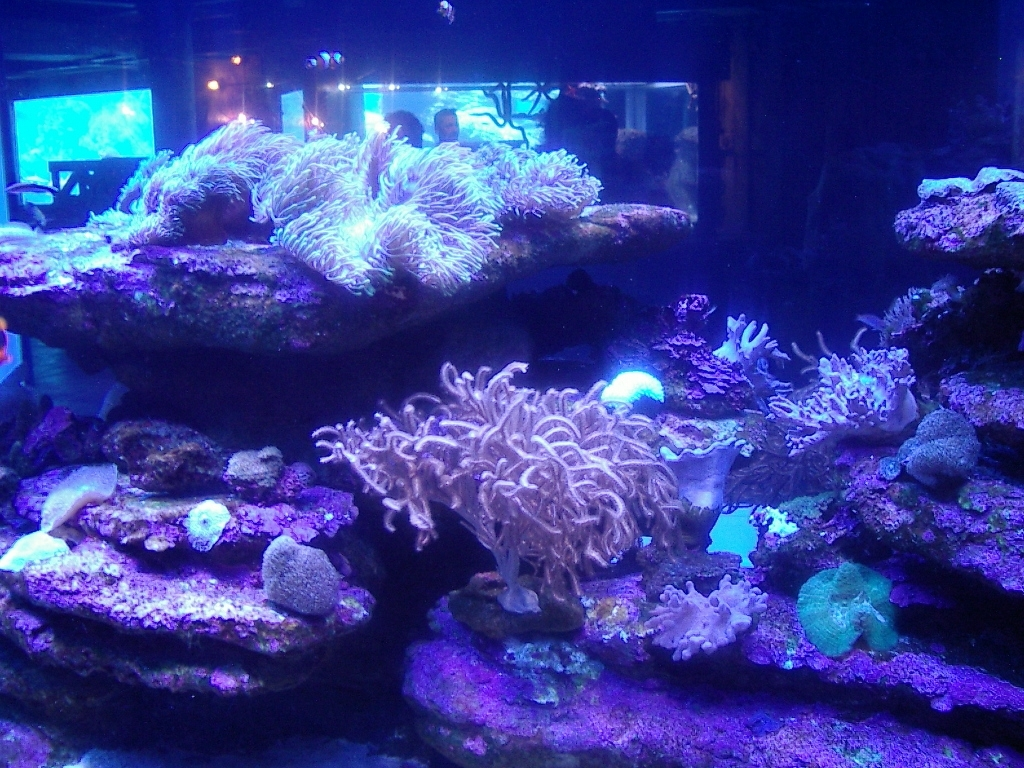Can you tell me what type of environment is depicted in this image? This image appears to depict an underwater marine environment, specifically an aquarium reef tank, which is designed to simulate a coral reef ecosystem. It features various species of corals and is illuminated by artificial lighting. 